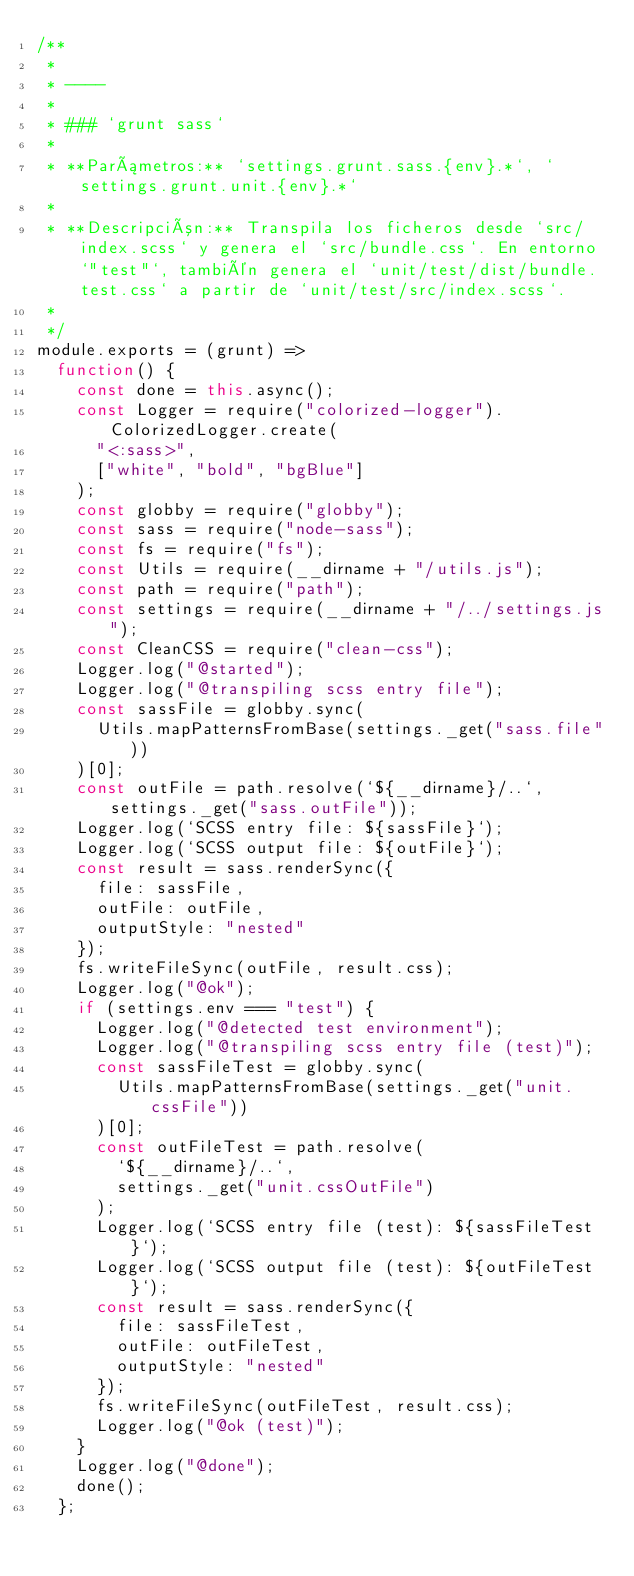<code> <loc_0><loc_0><loc_500><loc_500><_JavaScript_>/**
 *
 * ----
 *
 * ### `grunt sass`
 *
 * **Parámetros:** `settings.grunt.sass.{env}.*`, `settings.grunt.unit.{env}.*`
 *
 * **Descripción:** Transpila los ficheros desde `src/index.scss` y genera el `src/bundle.css`. En entorno `"test"`, también genera el `unit/test/dist/bundle.test.css` a partir de `unit/test/src/index.scss`.
 *
 */
module.exports = (grunt) =>
	function() {
		const done = this.async();
		const Logger = require("colorized-logger").ColorizedLogger.create(
			"<:sass>",
			["white", "bold", "bgBlue"]
		);
		const globby = require("globby");
		const sass = require("node-sass");
		const fs = require("fs");
		const Utils = require(__dirname + "/utils.js");
		const path = require("path");
		const settings = require(__dirname + "/../settings.js");
		const CleanCSS = require("clean-css");
		Logger.log("@started");
		Logger.log("@transpiling scss entry file");
		const sassFile = globby.sync(
			Utils.mapPatternsFromBase(settings._get("sass.file"))
		)[0];
		const outFile = path.resolve(`${__dirname}/..`,settings._get("sass.outFile"));
		Logger.log(`SCSS entry file: ${sassFile}`);
		Logger.log(`SCSS output file: ${outFile}`);
		const result = sass.renderSync({
			file: sassFile,
			outFile: outFile,
			outputStyle: "nested"
		});
		fs.writeFileSync(outFile, result.css);
		Logger.log("@ok");
		if (settings.env === "test") {
			Logger.log("@detected test environment");
			Logger.log("@transpiling scss entry file (test)");
			const sassFileTest = globby.sync(
				Utils.mapPatternsFromBase(settings._get("unit.cssFile"))
			)[0];
			const outFileTest = path.resolve(
				`${__dirname}/..`,
				settings._get("unit.cssOutFile")
			);
			Logger.log(`SCSS entry file (test): ${sassFileTest}`);
			Logger.log(`SCSS output file (test): ${outFileTest}`);
			const result = sass.renderSync({
				file: sassFileTest,
				outFile: outFileTest,
				outputStyle: "nested"
			});
			fs.writeFileSync(outFileTest, result.css);
			Logger.log("@ok (test)");
		}
		Logger.log("@done");
		done();
	};
</code> 